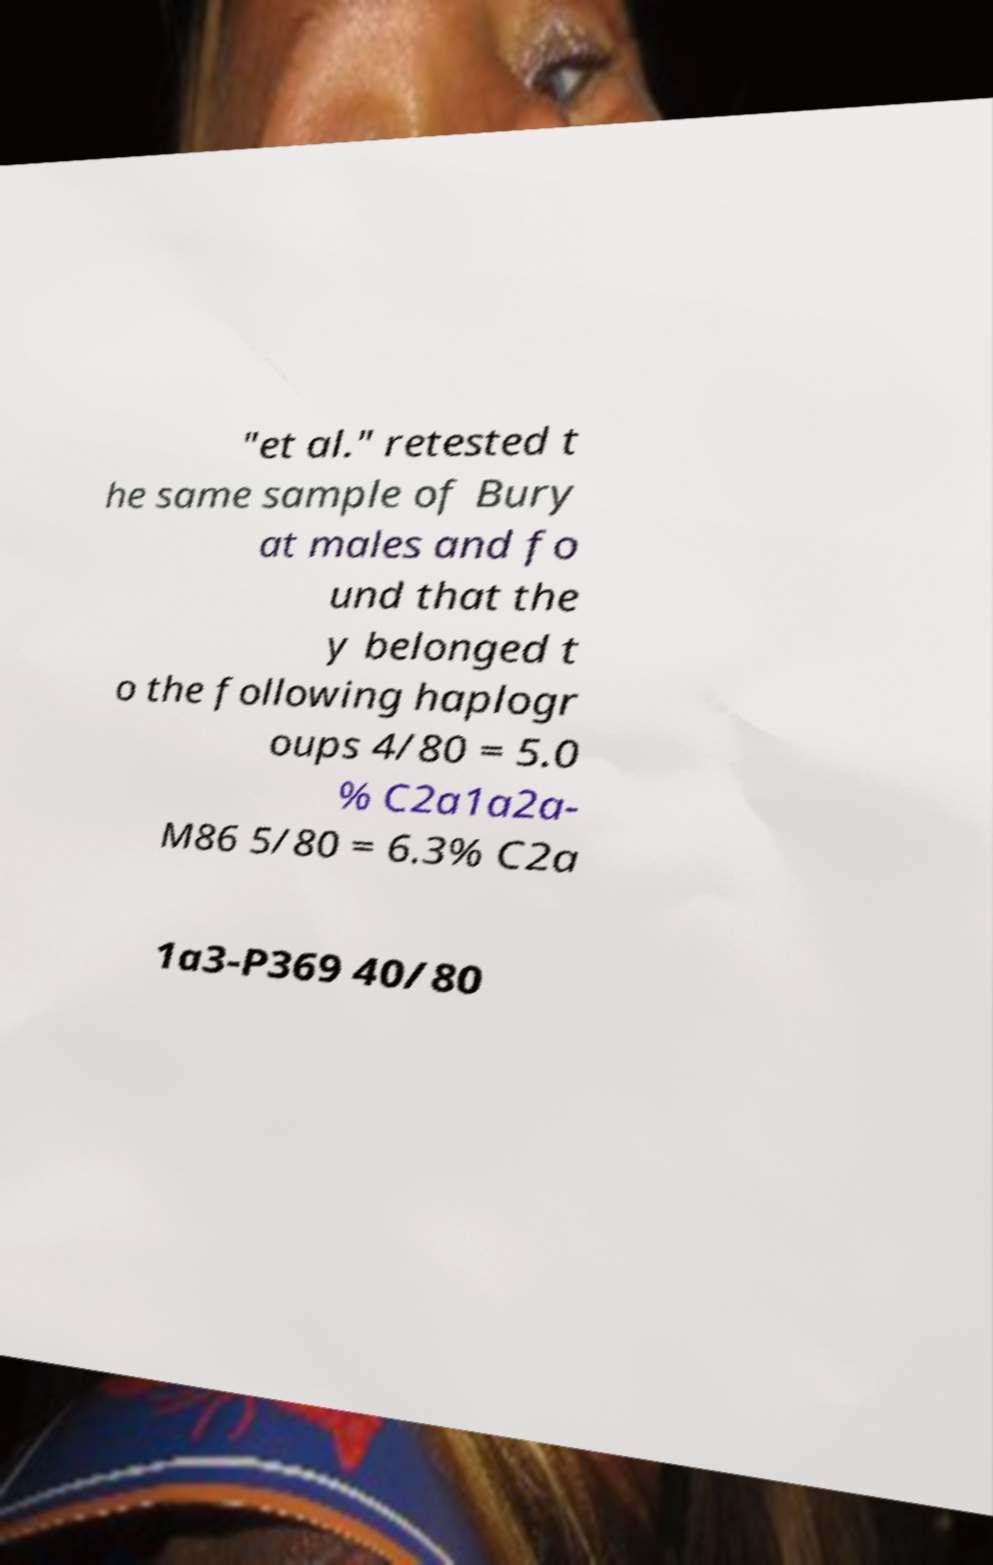Please identify and transcribe the text found in this image. "et al." retested t he same sample of Bury at males and fo und that the y belonged t o the following haplogr oups 4/80 = 5.0 % C2a1a2a- M86 5/80 = 6.3% C2a 1a3-P369 40/80 